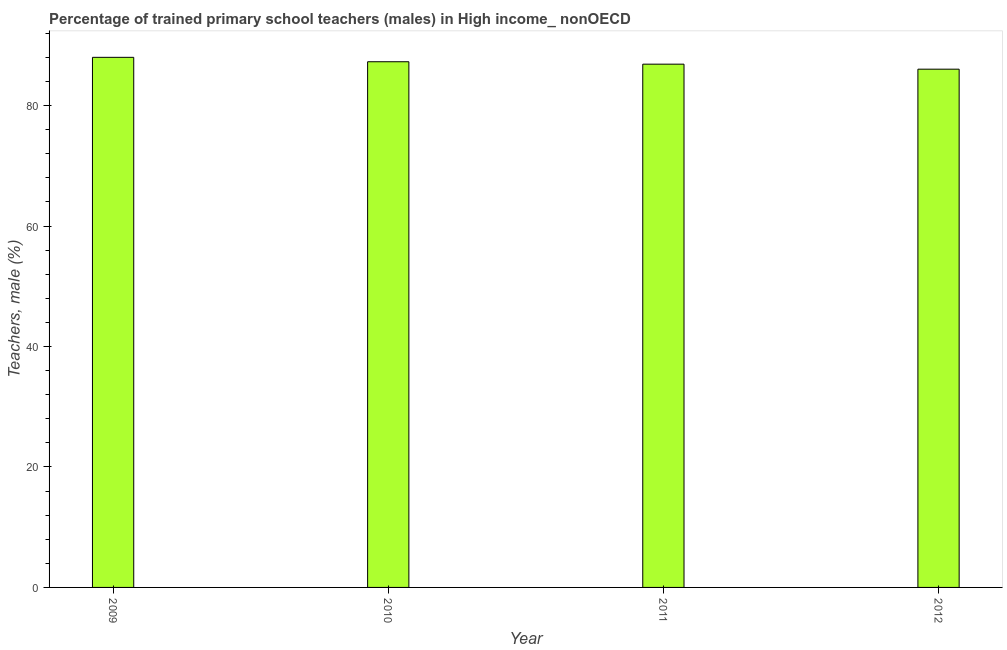What is the title of the graph?
Offer a very short reply. Percentage of trained primary school teachers (males) in High income_ nonOECD. What is the label or title of the Y-axis?
Provide a short and direct response. Teachers, male (%). What is the percentage of trained male teachers in 2009?
Offer a very short reply. 88.01. Across all years, what is the maximum percentage of trained male teachers?
Give a very brief answer. 88.01. Across all years, what is the minimum percentage of trained male teachers?
Provide a short and direct response. 86.04. What is the sum of the percentage of trained male teachers?
Make the answer very short. 348.19. What is the difference between the percentage of trained male teachers in 2009 and 2011?
Give a very brief answer. 1.13. What is the average percentage of trained male teachers per year?
Ensure brevity in your answer.  87.05. What is the median percentage of trained male teachers?
Offer a very short reply. 87.07. In how many years, is the percentage of trained male teachers greater than 8 %?
Your response must be concise. 4. Do a majority of the years between 2010 and 2012 (inclusive) have percentage of trained male teachers greater than 44 %?
Your response must be concise. Yes. Is the percentage of trained male teachers in 2011 less than that in 2012?
Your answer should be very brief. No. Is the difference between the percentage of trained male teachers in 2011 and 2012 greater than the difference between any two years?
Make the answer very short. No. What is the difference between the highest and the second highest percentage of trained male teachers?
Your answer should be very brief. 0.73. What is the difference between the highest and the lowest percentage of trained male teachers?
Ensure brevity in your answer.  1.97. In how many years, is the percentage of trained male teachers greater than the average percentage of trained male teachers taken over all years?
Make the answer very short. 2. Are the values on the major ticks of Y-axis written in scientific E-notation?
Your response must be concise. No. What is the Teachers, male (%) of 2009?
Offer a very short reply. 88.01. What is the Teachers, male (%) of 2010?
Offer a terse response. 87.27. What is the Teachers, male (%) in 2011?
Your answer should be very brief. 86.87. What is the Teachers, male (%) in 2012?
Give a very brief answer. 86.04. What is the difference between the Teachers, male (%) in 2009 and 2010?
Your answer should be very brief. 0.73. What is the difference between the Teachers, male (%) in 2009 and 2011?
Make the answer very short. 1.13. What is the difference between the Teachers, male (%) in 2009 and 2012?
Ensure brevity in your answer.  1.97. What is the difference between the Teachers, male (%) in 2010 and 2011?
Offer a very short reply. 0.4. What is the difference between the Teachers, male (%) in 2010 and 2012?
Offer a terse response. 1.23. What is the difference between the Teachers, male (%) in 2011 and 2012?
Your response must be concise. 0.83. What is the ratio of the Teachers, male (%) in 2009 to that in 2010?
Your answer should be very brief. 1.01. What is the ratio of the Teachers, male (%) in 2009 to that in 2011?
Make the answer very short. 1.01. What is the ratio of the Teachers, male (%) in 2010 to that in 2012?
Your answer should be very brief. 1.01. What is the ratio of the Teachers, male (%) in 2011 to that in 2012?
Your answer should be very brief. 1.01. 